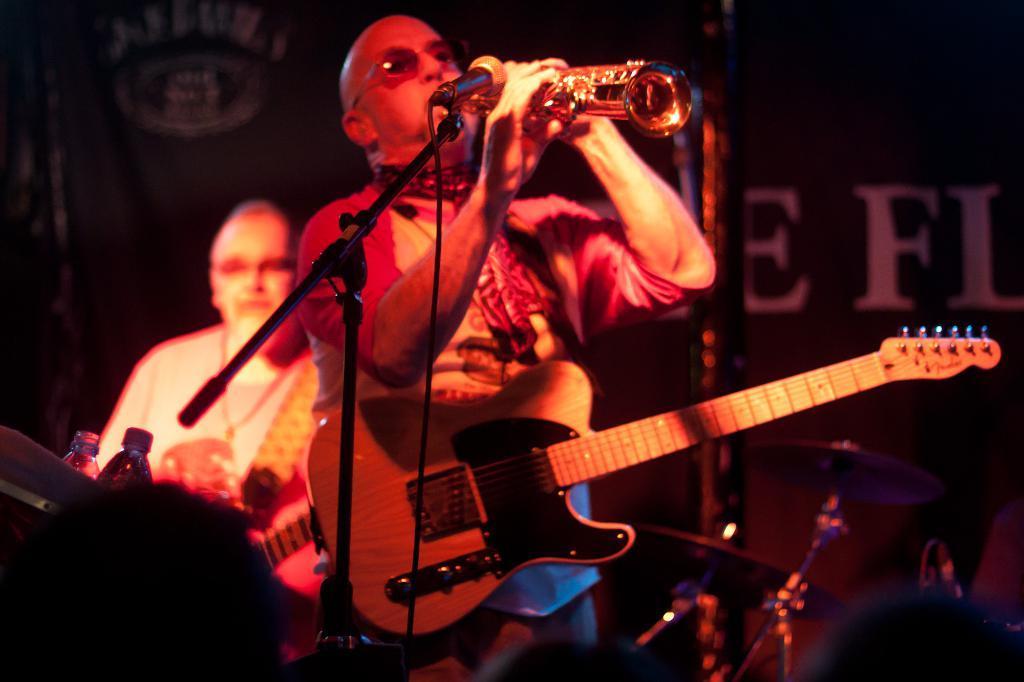Please provide a concise description of this image. In this image, In the middle there is a ,man standing and he is carrying a music instrument which is in yellow color, He is holding a music instrument, There is a microphone which is in black color, In the background there is a person sitting and there are some bottles kept on the table in the left side. 